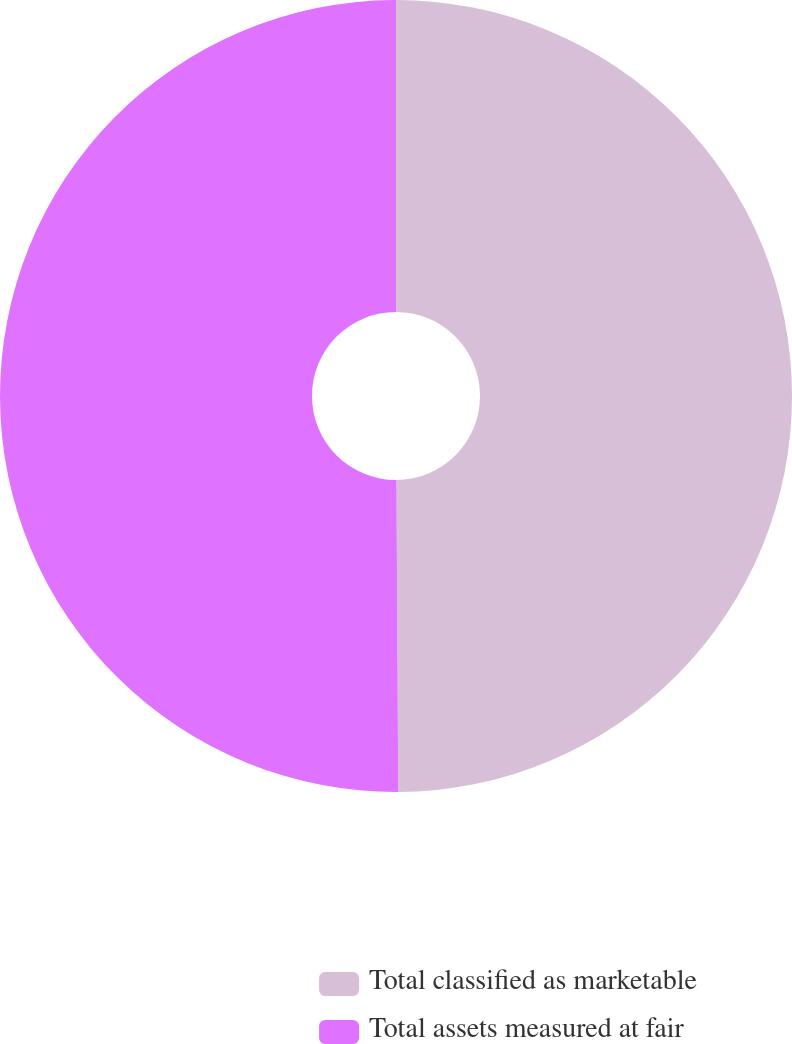Convert chart to OTSL. <chart><loc_0><loc_0><loc_500><loc_500><pie_chart><fcel>Total classified as marketable<fcel>Total assets measured at fair<nl><fcel>49.91%<fcel>50.09%<nl></chart> 